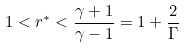Convert formula to latex. <formula><loc_0><loc_0><loc_500><loc_500>1 < r ^ { * } < \frac { \gamma + 1 } { \gamma - 1 } = 1 + \frac { 2 } { \Gamma }</formula> 